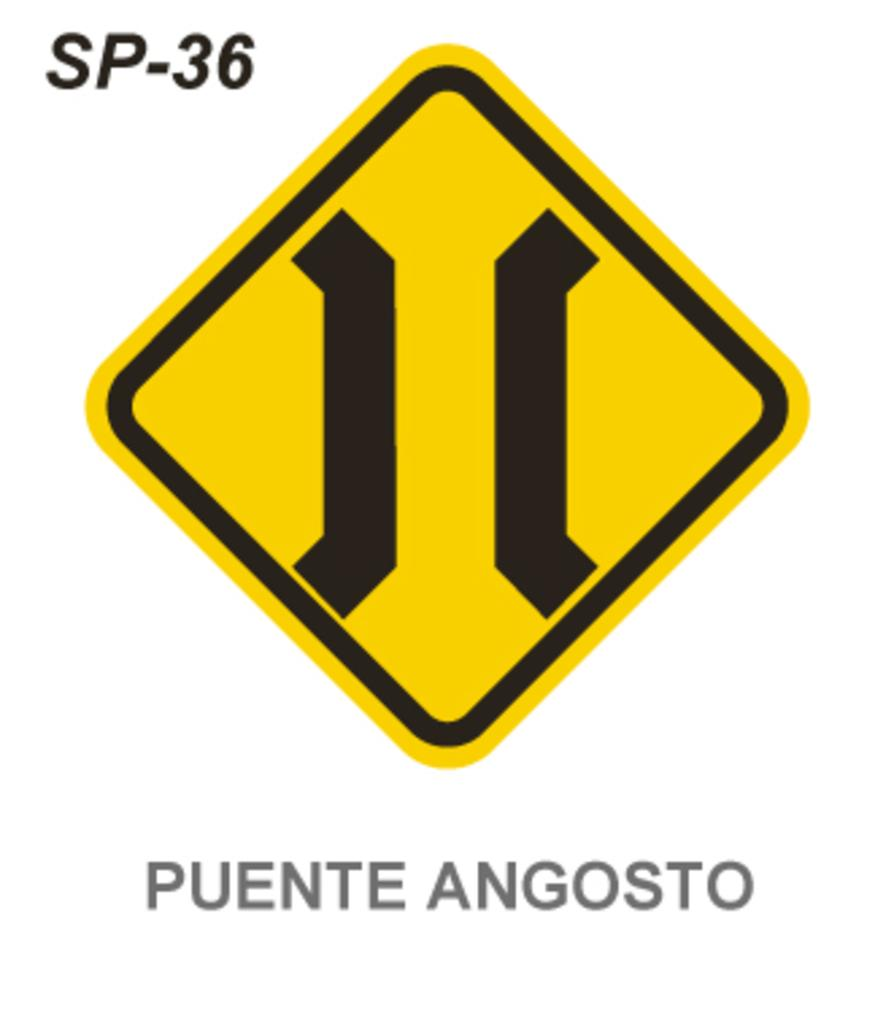<image>
Create a compact narrative representing the image presented. A black and yellow symbol sign with Puente Angosto written underneath it. 